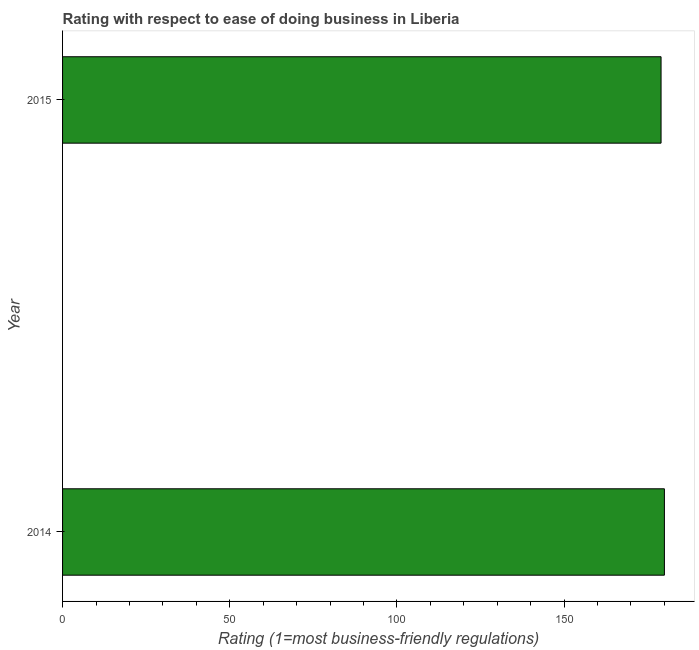Does the graph contain any zero values?
Your answer should be very brief. No. Does the graph contain grids?
Provide a succinct answer. No. What is the title of the graph?
Provide a succinct answer. Rating with respect to ease of doing business in Liberia. What is the label or title of the X-axis?
Ensure brevity in your answer.  Rating (1=most business-friendly regulations). What is the ease of doing business index in 2015?
Provide a short and direct response. 179. Across all years, what is the maximum ease of doing business index?
Provide a short and direct response. 180. Across all years, what is the minimum ease of doing business index?
Offer a very short reply. 179. In which year was the ease of doing business index maximum?
Offer a very short reply. 2014. In which year was the ease of doing business index minimum?
Offer a terse response. 2015. What is the sum of the ease of doing business index?
Provide a short and direct response. 359. What is the average ease of doing business index per year?
Your answer should be very brief. 179. What is the median ease of doing business index?
Offer a very short reply. 179.5. In how many years, is the ease of doing business index greater than 90 ?
Your answer should be very brief. 2. What is the ratio of the ease of doing business index in 2014 to that in 2015?
Offer a terse response. 1.01. Is the ease of doing business index in 2014 less than that in 2015?
Ensure brevity in your answer.  No. How many years are there in the graph?
Your response must be concise. 2. Are the values on the major ticks of X-axis written in scientific E-notation?
Your response must be concise. No. What is the Rating (1=most business-friendly regulations) in 2014?
Make the answer very short. 180. What is the Rating (1=most business-friendly regulations) in 2015?
Keep it short and to the point. 179. 